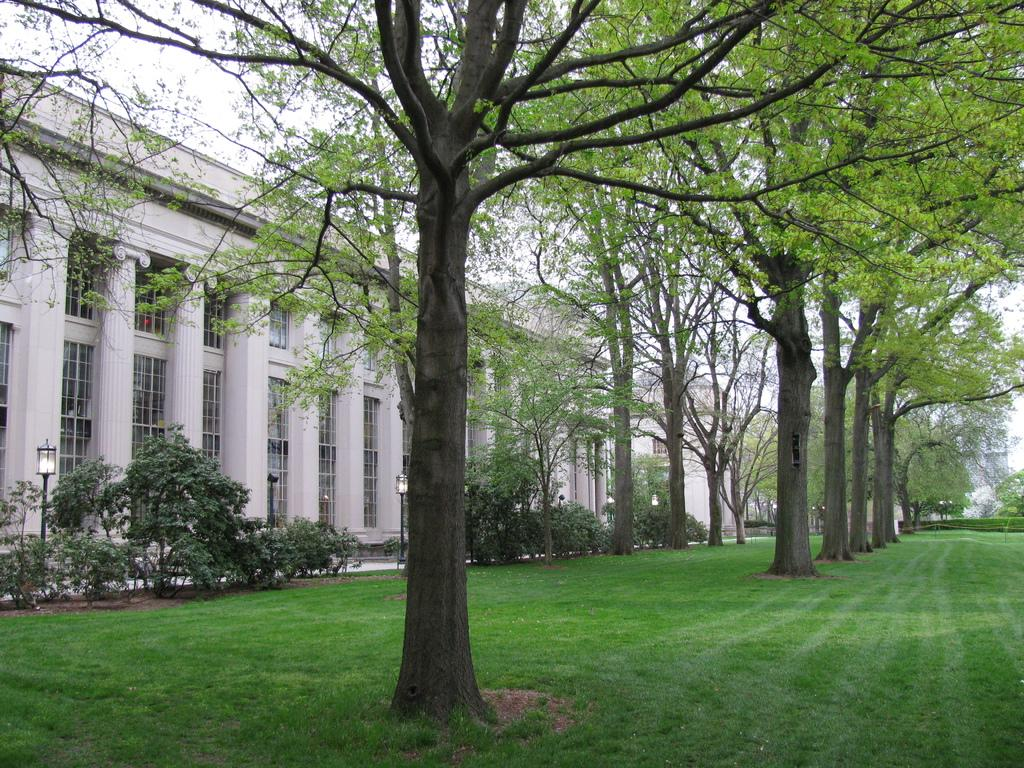What type of vegetation can be seen in the image? There are trees in the image. What is attached to the poles on the left side of the trees? There are lights attached to the poles on the left side of the trees. What type of structure is present in the image? There is a building in the image. What is visible behind the building in the image? The sky is visible behind the building. What type of payment system is being discussed by the committee in the image? There is no committee or payment system present in the image. What type of pump is visible in the image? There is no pump present in the image. 